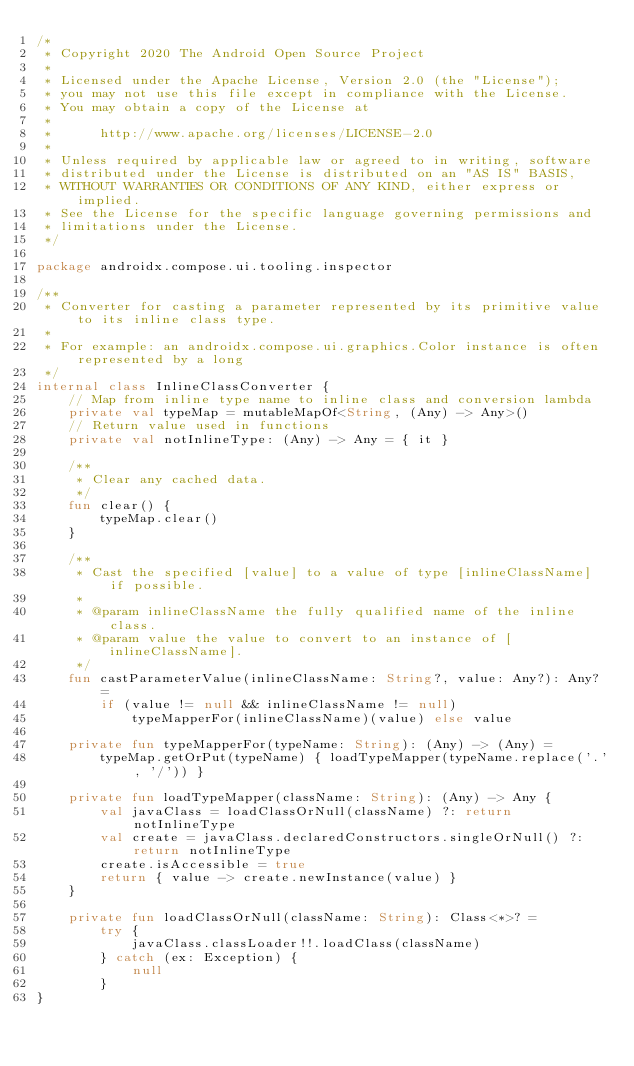<code> <loc_0><loc_0><loc_500><loc_500><_Kotlin_>/*
 * Copyright 2020 The Android Open Source Project
 *
 * Licensed under the Apache License, Version 2.0 (the "License");
 * you may not use this file except in compliance with the License.
 * You may obtain a copy of the License at
 *
 *      http://www.apache.org/licenses/LICENSE-2.0
 *
 * Unless required by applicable law or agreed to in writing, software
 * distributed under the License is distributed on an "AS IS" BASIS,
 * WITHOUT WARRANTIES OR CONDITIONS OF ANY KIND, either express or implied.
 * See the License for the specific language governing permissions and
 * limitations under the License.
 */

package androidx.compose.ui.tooling.inspector

/**
 * Converter for casting a parameter represented by its primitive value to its inline class type.
 *
 * For example: an androidx.compose.ui.graphics.Color instance is often represented by a long
 */
internal class InlineClassConverter {
    // Map from inline type name to inline class and conversion lambda
    private val typeMap = mutableMapOf<String, (Any) -> Any>()
    // Return value used in functions
    private val notInlineType: (Any) -> Any = { it }

    /**
     * Clear any cached data.
     */
    fun clear() {
        typeMap.clear()
    }

    /**
     * Cast the specified [value] to a value of type [inlineClassName] if possible.
     *
     * @param inlineClassName the fully qualified name of the inline class.
     * @param value the value to convert to an instance of [inlineClassName].
     */
    fun castParameterValue(inlineClassName: String?, value: Any?): Any? =
        if (value != null && inlineClassName != null)
            typeMapperFor(inlineClassName)(value) else value

    private fun typeMapperFor(typeName: String): (Any) -> (Any) =
        typeMap.getOrPut(typeName) { loadTypeMapper(typeName.replace('.', '/')) }

    private fun loadTypeMapper(className: String): (Any) -> Any {
        val javaClass = loadClassOrNull(className) ?: return notInlineType
        val create = javaClass.declaredConstructors.singleOrNull() ?: return notInlineType
        create.isAccessible = true
        return { value -> create.newInstance(value) }
    }

    private fun loadClassOrNull(className: String): Class<*>? =
        try {
            javaClass.classLoader!!.loadClass(className)
        } catch (ex: Exception) {
            null
        }
}
</code> 